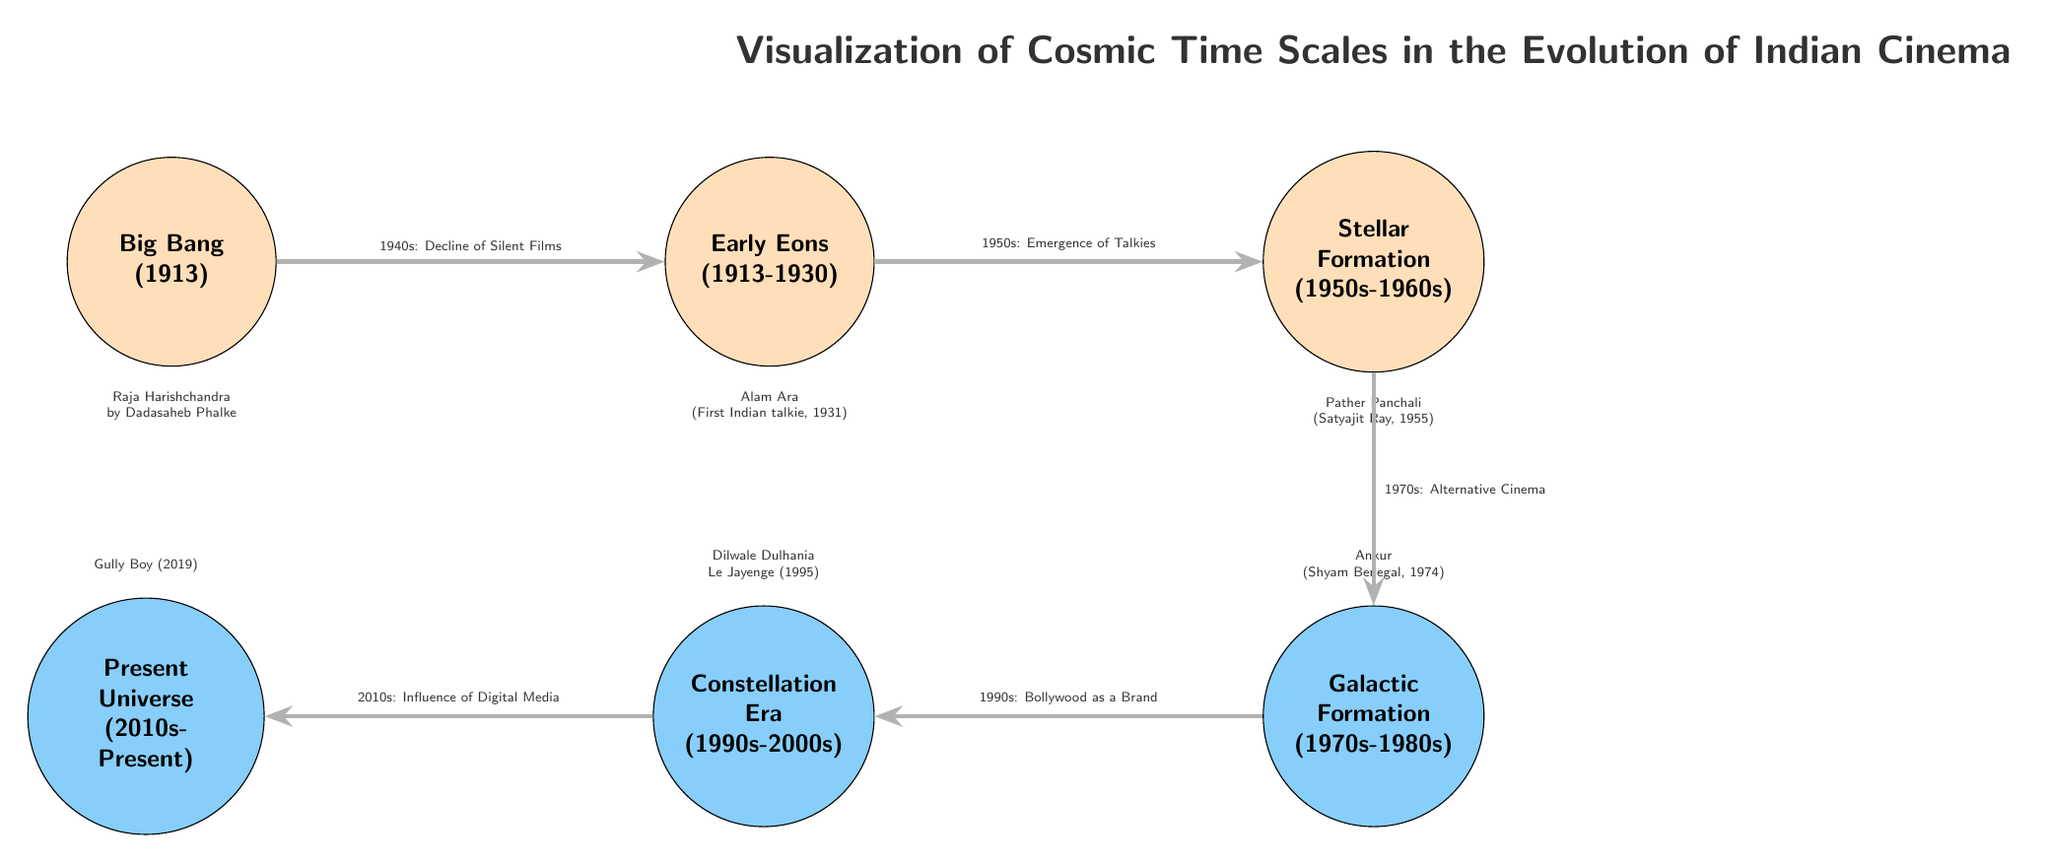What is the earliest event in the diagram? The earliest event is marked as "Big Bang" and corresponds to the year 1913, making it the first node in the timeline.
Answer: Big Bang (1913) How many main nodes are there in total? The main nodes in the diagram include Big Bang, Early Eons, Stellar Formation, Galactic Formation, Constellation Era, and Present Universe, which sums up to six nodes.
Answer: 6 What transition occurs between the Stellar Formation and Galactic Formation? The diagram shows that the transition between Stellar Formation and Galactic Formation involves the development of Alternative Cinema in the 1970s.
Answer: 1970s: Alternative Cinema Which film is associated with the Present Universe node? The Present Universe node is associated with the film "Gully Boy" released in 2019, as mentioned in the background information of that node.
Answer: Gully Boy (2019) What key event is noted in the Early Eons node? In the Early Eons node, it is noted that the decline of silent films occurred in the 1940s, marking a significant shift in the film industry.
Answer: 1940s: Decline of Silent Films Which node directly connects to the Stellar Formation? The node that directly connects to Stellar Formation is the Early Eons node, indicating a progression from the early years of cinema into the more developed periods represented in Stellar and Galactic formations.
Answer: Early Eons What is the thematic focus of the diagram? The thematic focus of the diagram is to visualize the cosmic time scales related to the evolution of Indian cinema over various decades and significant film milestones.
Answer: Visualization of Cosmic Time Scales in the Evolution of Indian Cinema What transition occurs between the Constellation Era and Present Universe? Between the Constellation Era and Present Universe, the transition highlights the influence of digital media, indicating technological advancements impacting cinema.
Answer: 2010s: Influence of Digital Media 